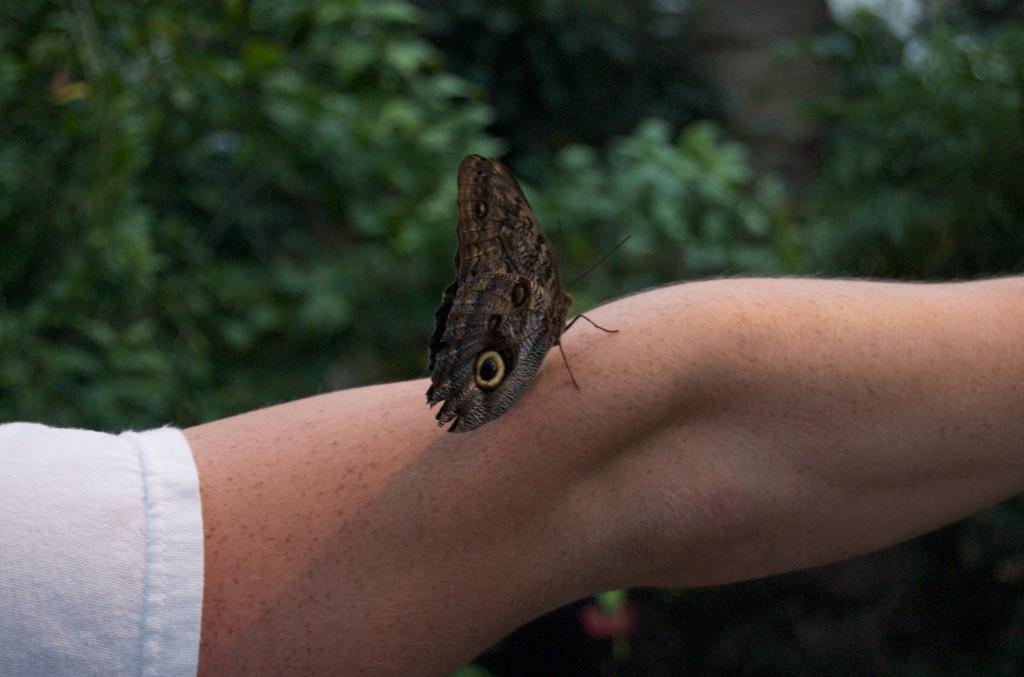What is the main subject of the image? The main subject of the image is a butterfly. Where is the butterfly located in the image? The butterfly is on a person's hand. What can be seen in the background of the image? There are trees in the background of the image. What type of fog can be seen surrounding the butterfly in the image? There is no fog present in the image; it features a butterfly on a person's hand with trees in the background. What type of pickle is the person holding in the image? There is no pickle present in the image. What is the butterfly using as a basin in the image? The butterfly is not using any basin in the image. 